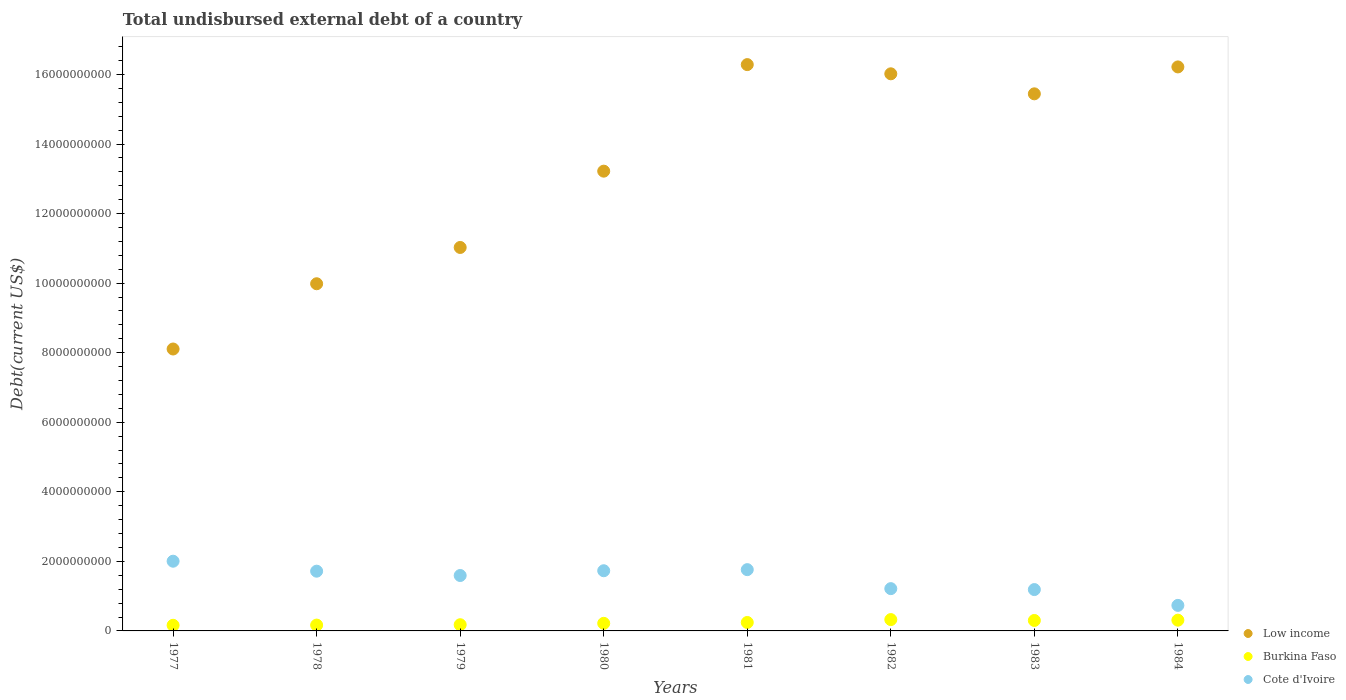How many different coloured dotlines are there?
Provide a succinct answer. 3. What is the total undisbursed external debt in Low income in 1982?
Keep it short and to the point. 1.60e+1. Across all years, what is the maximum total undisbursed external debt in Burkina Faso?
Ensure brevity in your answer.  3.26e+08. Across all years, what is the minimum total undisbursed external debt in Cote d'Ivoire?
Make the answer very short. 7.34e+08. What is the total total undisbursed external debt in Low income in the graph?
Provide a short and direct response. 1.06e+11. What is the difference between the total undisbursed external debt in Cote d'Ivoire in 1979 and that in 1984?
Provide a short and direct response. 8.59e+08. What is the difference between the total undisbursed external debt in Cote d'Ivoire in 1981 and the total undisbursed external debt in Low income in 1980?
Ensure brevity in your answer.  -1.15e+1. What is the average total undisbursed external debt in Burkina Faso per year?
Offer a terse response. 2.38e+08. In the year 1983, what is the difference between the total undisbursed external debt in Low income and total undisbursed external debt in Cote d'Ivoire?
Your answer should be compact. 1.43e+1. What is the ratio of the total undisbursed external debt in Burkina Faso in 1977 to that in 1982?
Your response must be concise. 0.5. What is the difference between the highest and the second highest total undisbursed external debt in Low income?
Provide a short and direct response. 6.65e+07. What is the difference between the highest and the lowest total undisbursed external debt in Low income?
Your answer should be very brief. 8.18e+09. Is the sum of the total undisbursed external debt in Burkina Faso in 1981 and 1983 greater than the maximum total undisbursed external debt in Low income across all years?
Your answer should be compact. No. Does the total undisbursed external debt in Cote d'Ivoire monotonically increase over the years?
Your response must be concise. No. How many dotlines are there?
Your answer should be compact. 3. How many years are there in the graph?
Make the answer very short. 8. What is the difference between two consecutive major ticks on the Y-axis?
Your answer should be very brief. 2.00e+09. What is the title of the graph?
Provide a succinct answer. Total undisbursed external debt of a country. Does "Zimbabwe" appear as one of the legend labels in the graph?
Provide a succinct answer. No. What is the label or title of the X-axis?
Your answer should be very brief. Years. What is the label or title of the Y-axis?
Your answer should be compact. Debt(current US$). What is the Debt(current US$) in Low income in 1977?
Keep it short and to the point. 8.11e+09. What is the Debt(current US$) in Burkina Faso in 1977?
Make the answer very short. 1.62e+08. What is the Debt(current US$) of Cote d'Ivoire in 1977?
Your response must be concise. 2.00e+09. What is the Debt(current US$) of Low income in 1978?
Keep it short and to the point. 9.98e+09. What is the Debt(current US$) in Burkina Faso in 1978?
Provide a short and direct response. 1.68e+08. What is the Debt(current US$) in Cote d'Ivoire in 1978?
Keep it short and to the point. 1.72e+09. What is the Debt(current US$) in Low income in 1979?
Keep it short and to the point. 1.10e+1. What is the Debt(current US$) of Burkina Faso in 1979?
Offer a very short reply. 1.78e+08. What is the Debt(current US$) of Cote d'Ivoire in 1979?
Offer a terse response. 1.59e+09. What is the Debt(current US$) of Low income in 1980?
Offer a very short reply. 1.32e+1. What is the Debt(current US$) in Burkina Faso in 1980?
Your answer should be compact. 2.18e+08. What is the Debt(current US$) in Cote d'Ivoire in 1980?
Your answer should be compact. 1.73e+09. What is the Debt(current US$) of Low income in 1981?
Keep it short and to the point. 1.63e+1. What is the Debt(current US$) in Burkina Faso in 1981?
Offer a terse response. 2.43e+08. What is the Debt(current US$) in Cote d'Ivoire in 1981?
Make the answer very short. 1.76e+09. What is the Debt(current US$) in Low income in 1982?
Keep it short and to the point. 1.60e+1. What is the Debt(current US$) in Burkina Faso in 1982?
Keep it short and to the point. 3.26e+08. What is the Debt(current US$) in Cote d'Ivoire in 1982?
Make the answer very short. 1.22e+09. What is the Debt(current US$) in Low income in 1983?
Your answer should be very brief. 1.54e+1. What is the Debt(current US$) of Burkina Faso in 1983?
Your response must be concise. 3.01e+08. What is the Debt(current US$) in Cote d'Ivoire in 1983?
Offer a very short reply. 1.19e+09. What is the Debt(current US$) in Low income in 1984?
Keep it short and to the point. 1.62e+1. What is the Debt(current US$) of Burkina Faso in 1984?
Offer a very short reply. 3.09e+08. What is the Debt(current US$) of Cote d'Ivoire in 1984?
Give a very brief answer. 7.34e+08. Across all years, what is the maximum Debt(current US$) of Low income?
Your answer should be compact. 1.63e+1. Across all years, what is the maximum Debt(current US$) in Burkina Faso?
Ensure brevity in your answer.  3.26e+08. Across all years, what is the maximum Debt(current US$) in Cote d'Ivoire?
Offer a very short reply. 2.00e+09. Across all years, what is the minimum Debt(current US$) of Low income?
Make the answer very short. 8.11e+09. Across all years, what is the minimum Debt(current US$) of Burkina Faso?
Make the answer very short. 1.62e+08. Across all years, what is the minimum Debt(current US$) of Cote d'Ivoire?
Ensure brevity in your answer.  7.34e+08. What is the total Debt(current US$) of Low income in the graph?
Offer a very short reply. 1.06e+11. What is the total Debt(current US$) in Burkina Faso in the graph?
Provide a succinct answer. 1.90e+09. What is the total Debt(current US$) of Cote d'Ivoire in the graph?
Provide a short and direct response. 1.19e+1. What is the difference between the Debt(current US$) of Low income in 1977 and that in 1978?
Your answer should be compact. -1.88e+09. What is the difference between the Debt(current US$) of Burkina Faso in 1977 and that in 1978?
Offer a terse response. -5.92e+06. What is the difference between the Debt(current US$) in Cote d'Ivoire in 1977 and that in 1978?
Your answer should be very brief. 2.87e+08. What is the difference between the Debt(current US$) in Low income in 1977 and that in 1979?
Your answer should be compact. -2.92e+09. What is the difference between the Debt(current US$) in Burkina Faso in 1977 and that in 1979?
Provide a short and direct response. -1.64e+07. What is the difference between the Debt(current US$) of Cote d'Ivoire in 1977 and that in 1979?
Ensure brevity in your answer.  4.11e+08. What is the difference between the Debt(current US$) in Low income in 1977 and that in 1980?
Offer a terse response. -5.11e+09. What is the difference between the Debt(current US$) in Burkina Faso in 1977 and that in 1980?
Your answer should be compact. -5.63e+07. What is the difference between the Debt(current US$) of Cote d'Ivoire in 1977 and that in 1980?
Offer a very short reply. 2.74e+08. What is the difference between the Debt(current US$) of Low income in 1977 and that in 1981?
Provide a short and direct response. -8.18e+09. What is the difference between the Debt(current US$) of Burkina Faso in 1977 and that in 1981?
Offer a terse response. -8.09e+07. What is the difference between the Debt(current US$) in Cote d'Ivoire in 1977 and that in 1981?
Provide a succinct answer. 2.42e+08. What is the difference between the Debt(current US$) of Low income in 1977 and that in 1982?
Your answer should be compact. -7.91e+09. What is the difference between the Debt(current US$) in Burkina Faso in 1977 and that in 1982?
Offer a very short reply. -1.64e+08. What is the difference between the Debt(current US$) of Cote d'Ivoire in 1977 and that in 1982?
Keep it short and to the point. 7.89e+08. What is the difference between the Debt(current US$) in Low income in 1977 and that in 1983?
Keep it short and to the point. -7.34e+09. What is the difference between the Debt(current US$) in Burkina Faso in 1977 and that in 1983?
Offer a terse response. -1.39e+08. What is the difference between the Debt(current US$) of Cote d'Ivoire in 1977 and that in 1983?
Offer a very short reply. 8.15e+08. What is the difference between the Debt(current US$) in Low income in 1977 and that in 1984?
Ensure brevity in your answer.  -8.11e+09. What is the difference between the Debt(current US$) of Burkina Faso in 1977 and that in 1984?
Your answer should be compact. -1.47e+08. What is the difference between the Debt(current US$) of Cote d'Ivoire in 1977 and that in 1984?
Offer a terse response. 1.27e+09. What is the difference between the Debt(current US$) in Low income in 1978 and that in 1979?
Give a very brief answer. -1.04e+09. What is the difference between the Debt(current US$) of Burkina Faso in 1978 and that in 1979?
Your response must be concise. -1.04e+07. What is the difference between the Debt(current US$) of Cote d'Ivoire in 1978 and that in 1979?
Ensure brevity in your answer.  1.24e+08. What is the difference between the Debt(current US$) of Low income in 1978 and that in 1980?
Keep it short and to the point. -3.24e+09. What is the difference between the Debt(current US$) of Burkina Faso in 1978 and that in 1980?
Ensure brevity in your answer.  -5.04e+07. What is the difference between the Debt(current US$) of Cote d'Ivoire in 1978 and that in 1980?
Provide a succinct answer. -1.27e+07. What is the difference between the Debt(current US$) in Low income in 1978 and that in 1981?
Your response must be concise. -6.30e+09. What is the difference between the Debt(current US$) in Burkina Faso in 1978 and that in 1981?
Provide a short and direct response. -7.50e+07. What is the difference between the Debt(current US$) of Cote d'Ivoire in 1978 and that in 1981?
Make the answer very short. -4.43e+07. What is the difference between the Debt(current US$) in Low income in 1978 and that in 1982?
Your response must be concise. -6.04e+09. What is the difference between the Debt(current US$) in Burkina Faso in 1978 and that in 1982?
Your answer should be very brief. -1.58e+08. What is the difference between the Debt(current US$) in Cote d'Ivoire in 1978 and that in 1982?
Ensure brevity in your answer.  5.02e+08. What is the difference between the Debt(current US$) in Low income in 1978 and that in 1983?
Provide a succinct answer. -5.46e+09. What is the difference between the Debt(current US$) of Burkina Faso in 1978 and that in 1983?
Ensure brevity in your answer.  -1.33e+08. What is the difference between the Debt(current US$) of Cote d'Ivoire in 1978 and that in 1983?
Ensure brevity in your answer.  5.29e+08. What is the difference between the Debt(current US$) of Low income in 1978 and that in 1984?
Keep it short and to the point. -6.23e+09. What is the difference between the Debt(current US$) of Burkina Faso in 1978 and that in 1984?
Offer a terse response. -1.41e+08. What is the difference between the Debt(current US$) of Cote d'Ivoire in 1978 and that in 1984?
Provide a succinct answer. 9.83e+08. What is the difference between the Debt(current US$) of Low income in 1979 and that in 1980?
Ensure brevity in your answer.  -2.19e+09. What is the difference between the Debt(current US$) of Burkina Faso in 1979 and that in 1980?
Your answer should be compact. -3.99e+07. What is the difference between the Debt(current US$) in Cote d'Ivoire in 1979 and that in 1980?
Provide a short and direct response. -1.37e+08. What is the difference between the Debt(current US$) in Low income in 1979 and that in 1981?
Make the answer very short. -5.26e+09. What is the difference between the Debt(current US$) in Burkina Faso in 1979 and that in 1981?
Your answer should be compact. -6.45e+07. What is the difference between the Debt(current US$) of Cote d'Ivoire in 1979 and that in 1981?
Your answer should be very brief. -1.69e+08. What is the difference between the Debt(current US$) in Low income in 1979 and that in 1982?
Your answer should be very brief. -4.99e+09. What is the difference between the Debt(current US$) in Burkina Faso in 1979 and that in 1982?
Your answer should be compact. -1.48e+08. What is the difference between the Debt(current US$) in Cote d'Ivoire in 1979 and that in 1982?
Give a very brief answer. 3.78e+08. What is the difference between the Debt(current US$) in Low income in 1979 and that in 1983?
Make the answer very short. -4.42e+09. What is the difference between the Debt(current US$) of Burkina Faso in 1979 and that in 1983?
Offer a very short reply. -1.22e+08. What is the difference between the Debt(current US$) of Cote d'Ivoire in 1979 and that in 1983?
Provide a short and direct response. 4.04e+08. What is the difference between the Debt(current US$) in Low income in 1979 and that in 1984?
Provide a short and direct response. -5.19e+09. What is the difference between the Debt(current US$) in Burkina Faso in 1979 and that in 1984?
Offer a very short reply. -1.31e+08. What is the difference between the Debt(current US$) in Cote d'Ivoire in 1979 and that in 1984?
Offer a terse response. 8.59e+08. What is the difference between the Debt(current US$) of Low income in 1980 and that in 1981?
Give a very brief answer. -3.06e+09. What is the difference between the Debt(current US$) of Burkina Faso in 1980 and that in 1981?
Provide a succinct answer. -2.46e+07. What is the difference between the Debt(current US$) of Cote d'Ivoire in 1980 and that in 1981?
Your answer should be very brief. -3.16e+07. What is the difference between the Debt(current US$) in Low income in 1980 and that in 1982?
Your answer should be very brief. -2.80e+09. What is the difference between the Debt(current US$) of Burkina Faso in 1980 and that in 1982?
Offer a terse response. -1.08e+08. What is the difference between the Debt(current US$) of Cote d'Ivoire in 1980 and that in 1982?
Keep it short and to the point. 5.15e+08. What is the difference between the Debt(current US$) of Low income in 1980 and that in 1983?
Provide a succinct answer. -2.22e+09. What is the difference between the Debt(current US$) of Burkina Faso in 1980 and that in 1983?
Make the answer very short. -8.23e+07. What is the difference between the Debt(current US$) in Cote d'Ivoire in 1980 and that in 1983?
Ensure brevity in your answer.  5.42e+08. What is the difference between the Debt(current US$) in Low income in 1980 and that in 1984?
Give a very brief answer. -3.00e+09. What is the difference between the Debt(current US$) of Burkina Faso in 1980 and that in 1984?
Make the answer very short. -9.08e+07. What is the difference between the Debt(current US$) in Cote d'Ivoire in 1980 and that in 1984?
Offer a very short reply. 9.96e+08. What is the difference between the Debt(current US$) of Low income in 1981 and that in 1982?
Your answer should be very brief. 2.65e+08. What is the difference between the Debt(current US$) of Burkina Faso in 1981 and that in 1982?
Provide a short and direct response. -8.32e+07. What is the difference between the Debt(current US$) of Cote d'Ivoire in 1981 and that in 1982?
Provide a succinct answer. 5.46e+08. What is the difference between the Debt(current US$) in Low income in 1981 and that in 1983?
Provide a succinct answer. 8.40e+08. What is the difference between the Debt(current US$) of Burkina Faso in 1981 and that in 1983?
Your response must be concise. -5.77e+07. What is the difference between the Debt(current US$) of Cote d'Ivoire in 1981 and that in 1983?
Provide a succinct answer. 5.73e+08. What is the difference between the Debt(current US$) in Low income in 1981 and that in 1984?
Provide a succinct answer. 6.65e+07. What is the difference between the Debt(current US$) in Burkina Faso in 1981 and that in 1984?
Your answer should be very brief. -6.62e+07. What is the difference between the Debt(current US$) in Cote d'Ivoire in 1981 and that in 1984?
Make the answer very short. 1.03e+09. What is the difference between the Debt(current US$) in Low income in 1982 and that in 1983?
Your answer should be very brief. 5.76e+08. What is the difference between the Debt(current US$) in Burkina Faso in 1982 and that in 1983?
Keep it short and to the point. 2.54e+07. What is the difference between the Debt(current US$) of Cote d'Ivoire in 1982 and that in 1983?
Keep it short and to the point. 2.68e+07. What is the difference between the Debt(current US$) of Low income in 1982 and that in 1984?
Offer a very short reply. -1.98e+08. What is the difference between the Debt(current US$) of Burkina Faso in 1982 and that in 1984?
Offer a terse response. 1.69e+07. What is the difference between the Debt(current US$) of Cote d'Ivoire in 1982 and that in 1984?
Offer a terse response. 4.82e+08. What is the difference between the Debt(current US$) of Low income in 1983 and that in 1984?
Ensure brevity in your answer.  -7.74e+08. What is the difference between the Debt(current US$) of Burkina Faso in 1983 and that in 1984?
Offer a very short reply. -8.50e+06. What is the difference between the Debt(current US$) of Cote d'Ivoire in 1983 and that in 1984?
Provide a short and direct response. 4.55e+08. What is the difference between the Debt(current US$) in Low income in 1977 and the Debt(current US$) in Burkina Faso in 1978?
Offer a very short reply. 7.94e+09. What is the difference between the Debt(current US$) of Low income in 1977 and the Debt(current US$) of Cote d'Ivoire in 1978?
Your answer should be compact. 6.39e+09. What is the difference between the Debt(current US$) of Burkina Faso in 1977 and the Debt(current US$) of Cote d'Ivoire in 1978?
Ensure brevity in your answer.  -1.56e+09. What is the difference between the Debt(current US$) of Low income in 1977 and the Debt(current US$) of Burkina Faso in 1979?
Your answer should be compact. 7.93e+09. What is the difference between the Debt(current US$) in Low income in 1977 and the Debt(current US$) in Cote d'Ivoire in 1979?
Your answer should be compact. 6.51e+09. What is the difference between the Debt(current US$) in Burkina Faso in 1977 and the Debt(current US$) in Cote d'Ivoire in 1979?
Your answer should be compact. -1.43e+09. What is the difference between the Debt(current US$) in Low income in 1977 and the Debt(current US$) in Burkina Faso in 1980?
Offer a very short reply. 7.89e+09. What is the difference between the Debt(current US$) of Low income in 1977 and the Debt(current US$) of Cote d'Ivoire in 1980?
Your response must be concise. 6.38e+09. What is the difference between the Debt(current US$) of Burkina Faso in 1977 and the Debt(current US$) of Cote d'Ivoire in 1980?
Offer a terse response. -1.57e+09. What is the difference between the Debt(current US$) of Low income in 1977 and the Debt(current US$) of Burkina Faso in 1981?
Provide a short and direct response. 7.86e+09. What is the difference between the Debt(current US$) in Low income in 1977 and the Debt(current US$) in Cote d'Ivoire in 1981?
Your response must be concise. 6.34e+09. What is the difference between the Debt(current US$) in Burkina Faso in 1977 and the Debt(current US$) in Cote d'Ivoire in 1981?
Give a very brief answer. -1.60e+09. What is the difference between the Debt(current US$) in Low income in 1977 and the Debt(current US$) in Burkina Faso in 1982?
Keep it short and to the point. 7.78e+09. What is the difference between the Debt(current US$) of Low income in 1977 and the Debt(current US$) of Cote d'Ivoire in 1982?
Ensure brevity in your answer.  6.89e+09. What is the difference between the Debt(current US$) in Burkina Faso in 1977 and the Debt(current US$) in Cote d'Ivoire in 1982?
Offer a very short reply. -1.05e+09. What is the difference between the Debt(current US$) in Low income in 1977 and the Debt(current US$) in Burkina Faso in 1983?
Give a very brief answer. 7.81e+09. What is the difference between the Debt(current US$) in Low income in 1977 and the Debt(current US$) in Cote d'Ivoire in 1983?
Ensure brevity in your answer.  6.92e+09. What is the difference between the Debt(current US$) in Burkina Faso in 1977 and the Debt(current US$) in Cote d'Ivoire in 1983?
Give a very brief answer. -1.03e+09. What is the difference between the Debt(current US$) of Low income in 1977 and the Debt(current US$) of Burkina Faso in 1984?
Your answer should be very brief. 7.80e+09. What is the difference between the Debt(current US$) in Low income in 1977 and the Debt(current US$) in Cote d'Ivoire in 1984?
Provide a short and direct response. 7.37e+09. What is the difference between the Debt(current US$) in Burkina Faso in 1977 and the Debt(current US$) in Cote d'Ivoire in 1984?
Offer a terse response. -5.72e+08. What is the difference between the Debt(current US$) in Low income in 1978 and the Debt(current US$) in Burkina Faso in 1979?
Provide a succinct answer. 9.80e+09. What is the difference between the Debt(current US$) in Low income in 1978 and the Debt(current US$) in Cote d'Ivoire in 1979?
Offer a terse response. 8.39e+09. What is the difference between the Debt(current US$) in Burkina Faso in 1978 and the Debt(current US$) in Cote d'Ivoire in 1979?
Your answer should be compact. -1.43e+09. What is the difference between the Debt(current US$) in Low income in 1978 and the Debt(current US$) in Burkina Faso in 1980?
Provide a succinct answer. 9.76e+09. What is the difference between the Debt(current US$) of Low income in 1978 and the Debt(current US$) of Cote d'Ivoire in 1980?
Offer a very short reply. 8.25e+09. What is the difference between the Debt(current US$) in Burkina Faso in 1978 and the Debt(current US$) in Cote d'Ivoire in 1980?
Offer a terse response. -1.56e+09. What is the difference between the Debt(current US$) of Low income in 1978 and the Debt(current US$) of Burkina Faso in 1981?
Provide a short and direct response. 9.74e+09. What is the difference between the Debt(current US$) in Low income in 1978 and the Debt(current US$) in Cote d'Ivoire in 1981?
Your response must be concise. 8.22e+09. What is the difference between the Debt(current US$) in Burkina Faso in 1978 and the Debt(current US$) in Cote d'Ivoire in 1981?
Offer a very short reply. -1.59e+09. What is the difference between the Debt(current US$) of Low income in 1978 and the Debt(current US$) of Burkina Faso in 1982?
Offer a very short reply. 9.66e+09. What is the difference between the Debt(current US$) of Low income in 1978 and the Debt(current US$) of Cote d'Ivoire in 1982?
Give a very brief answer. 8.77e+09. What is the difference between the Debt(current US$) in Burkina Faso in 1978 and the Debt(current US$) in Cote d'Ivoire in 1982?
Give a very brief answer. -1.05e+09. What is the difference between the Debt(current US$) of Low income in 1978 and the Debt(current US$) of Burkina Faso in 1983?
Your answer should be very brief. 9.68e+09. What is the difference between the Debt(current US$) in Low income in 1978 and the Debt(current US$) in Cote d'Ivoire in 1983?
Your answer should be compact. 8.79e+09. What is the difference between the Debt(current US$) of Burkina Faso in 1978 and the Debt(current US$) of Cote d'Ivoire in 1983?
Offer a terse response. -1.02e+09. What is the difference between the Debt(current US$) of Low income in 1978 and the Debt(current US$) of Burkina Faso in 1984?
Give a very brief answer. 9.67e+09. What is the difference between the Debt(current US$) of Low income in 1978 and the Debt(current US$) of Cote d'Ivoire in 1984?
Make the answer very short. 9.25e+09. What is the difference between the Debt(current US$) of Burkina Faso in 1978 and the Debt(current US$) of Cote d'Ivoire in 1984?
Ensure brevity in your answer.  -5.66e+08. What is the difference between the Debt(current US$) of Low income in 1979 and the Debt(current US$) of Burkina Faso in 1980?
Your response must be concise. 1.08e+1. What is the difference between the Debt(current US$) in Low income in 1979 and the Debt(current US$) in Cote d'Ivoire in 1980?
Offer a terse response. 9.30e+09. What is the difference between the Debt(current US$) in Burkina Faso in 1979 and the Debt(current US$) in Cote d'Ivoire in 1980?
Ensure brevity in your answer.  -1.55e+09. What is the difference between the Debt(current US$) of Low income in 1979 and the Debt(current US$) of Burkina Faso in 1981?
Offer a terse response. 1.08e+1. What is the difference between the Debt(current US$) in Low income in 1979 and the Debt(current US$) in Cote d'Ivoire in 1981?
Make the answer very short. 9.26e+09. What is the difference between the Debt(current US$) in Burkina Faso in 1979 and the Debt(current US$) in Cote d'Ivoire in 1981?
Offer a terse response. -1.58e+09. What is the difference between the Debt(current US$) in Low income in 1979 and the Debt(current US$) in Burkina Faso in 1982?
Keep it short and to the point. 1.07e+1. What is the difference between the Debt(current US$) of Low income in 1979 and the Debt(current US$) of Cote d'Ivoire in 1982?
Offer a very short reply. 9.81e+09. What is the difference between the Debt(current US$) of Burkina Faso in 1979 and the Debt(current US$) of Cote d'Ivoire in 1982?
Your response must be concise. -1.04e+09. What is the difference between the Debt(current US$) in Low income in 1979 and the Debt(current US$) in Burkina Faso in 1983?
Your answer should be compact. 1.07e+1. What is the difference between the Debt(current US$) in Low income in 1979 and the Debt(current US$) in Cote d'Ivoire in 1983?
Your response must be concise. 9.84e+09. What is the difference between the Debt(current US$) in Burkina Faso in 1979 and the Debt(current US$) in Cote d'Ivoire in 1983?
Ensure brevity in your answer.  -1.01e+09. What is the difference between the Debt(current US$) in Low income in 1979 and the Debt(current US$) in Burkina Faso in 1984?
Make the answer very short. 1.07e+1. What is the difference between the Debt(current US$) in Low income in 1979 and the Debt(current US$) in Cote d'Ivoire in 1984?
Offer a terse response. 1.03e+1. What is the difference between the Debt(current US$) in Burkina Faso in 1979 and the Debt(current US$) in Cote d'Ivoire in 1984?
Your answer should be very brief. -5.56e+08. What is the difference between the Debt(current US$) of Low income in 1980 and the Debt(current US$) of Burkina Faso in 1981?
Offer a terse response. 1.30e+1. What is the difference between the Debt(current US$) of Low income in 1980 and the Debt(current US$) of Cote d'Ivoire in 1981?
Your answer should be very brief. 1.15e+1. What is the difference between the Debt(current US$) of Burkina Faso in 1980 and the Debt(current US$) of Cote d'Ivoire in 1981?
Your response must be concise. -1.54e+09. What is the difference between the Debt(current US$) of Low income in 1980 and the Debt(current US$) of Burkina Faso in 1982?
Make the answer very short. 1.29e+1. What is the difference between the Debt(current US$) of Low income in 1980 and the Debt(current US$) of Cote d'Ivoire in 1982?
Make the answer very short. 1.20e+1. What is the difference between the Debt(current US$) in Burkina Faso in 1980 and the Debt(current US$) in Cote d'Ivoire in 1982?
Ensure brevity in your answer.  -9.98e+08. What is the difference between the Debt(current US$) of Low income in 1980 and the Debt(current US$) of Burkina Faso in 1983?
Your answer should be compact. 1.29e+1. What is the difference between the Debt(current US$) of Low income in 1980 and the Debt(current US$) of Cote d'Ivoire in 1983?
Offer a very short reply. 1.20e+1. What is the difference between the Debt(current US$) in Burkina Faso in 1980 and the Debt(current US$) in Cote d'Ivoire in 1983?
Make the answer very short. -9.71e+08. What is the difference between the Debt(current US$) of Low income in 1980 and the Debt(current US$) of Burkina Faso in 1984?
Keep it short and to the point. 1.29e+1. What is the difference between the Debt(current US$) of Low income in 1980 and the Debt(current US$) of Cote d'Ivoire in 1984?
Keep it short and to the point. 1.25e+1. What is the difference between the Debt(current US$) in Burkina Faso in 1980 and the Debt(current US$) in Cote d'Ivoire in 1984?
Your answer should be compact. -5.16e+08. What is the difference between the Debt(current US$) of Low income in 1981 and the Debt(current US$) of Burkina Faso in 1982?
Ensure brevity in your answer.  1.60e+1. What is the difference between the Debt(current US$) of Low income in 1981 and the Debt(current US$) of Cote d'Ivoire in 1982?
Ensure brevity in your answer.  1.51e+1. What is the difference between the Debt(current US$) of Burkina Faso in 1981 and the Debt(current US$) of Cote d'Ivoire in 1982?
Give a very brief answer. -9.73e+08. What is the difference between the Debt(current US$) of Low income in 1981 and the Debt(current US$) of Burkina Faso in 1983?
Offer a terse response. 1.60e+1. What is the difference between the Debt(current US$) in Low income in 1981 and the Debt(current US$) in Cote d'Ivoire in 1983?
Provide a succinct answer. 1.51e+1. What is the difference between the Debt(current US$) in Burkina Faso in 1981 and the Debt(current US$) in Cote d'Ivoire in 1983?
Give a very brief answer. -9.46e+08. What is the difference between the Debt(current US$) in Low income in 1981 and the Debt(current US$) in Burkina Faso in 1984?
Offer a terse response. 1.60e+1. What is the difference between the Debt(current US$) in Low income in 1981 and the Debt(current US$) in Cote d'Ivoire in 1984?
Your answer should be very brief. 1.55e+1. What is the difference between the Debt(current US$) in Burkina Faso in 1981 and the Debt(current US$) in Cote d'Ivoire in 1984?
Provide a short and direct response. -4.91e+08. What is the difference between the Debt(current US$) of Low income in 1982 and the Debt(current US$) of Burkina Faso in 1983?
Your answer should be compact. 1.57e+1. What is the difference between the Debt(current US$) of Low income in 1982 and the Debt(current US$) of Cote d'Ivoire in 1983?
Your answer should be very brief. 1.48e+1. What is the difference between the Debt(current US$) in Burkina Faso in 1982 and the Debt(current US$) in Cote d'Ivoire in 1983?
Your answer should be compact. -8.63e+08. What is the difference between the Debt(current US$) in Low income in 1982 and the Debt(current US$) in Burkina Faso in 1984?
Your answer should be compact. 1.57e+1. What is the difference between the Debt(current US$) of Low income in 1982 and the Debt(current US$) of Cote d'Ivoire in 1984?
Provide a succinct answer. 1.53e+1. What is the difference between the Debt(current US$) of Burkina Faso in 1982 and the Debt(current US$) of Cote d'Ivoire in 1984?
Make the answer very short. -4.08e+08. What is the difference between the Debt(current US$) in Low income in 1983 and the Debt(current US$) in Burkina Faso in 1984?
Your answer should be compact. 1.51e+1. What is the difference between the Debt(current US$) of Low income in 1983 and the Debt(current US$) of Cote d'Ivoire in 1984?
Your answer should be very brief. 1.47e+1. What is the difference between the Debt(current US$) of Burkina Faso in 1983 and the Debt(current US$) of Cote d'Ivoire in 1984?
Keep it short and to the point. -4.34e+08. What is the average Debt(current US$) of Low income per year?
Provide a short and direct response. 1.33e+1. What is the average Debt(current US$) in Burkina Faso per year?
Offer a very short reply. 2.38e+08. What is the average Debt(current US$) of Cote d'Ivoire per year?
Provide a short and direct response. 1.49e+09. In the year 1977, what is the difference between the Debt(current US$) of Low income and Debt(current US$) of Burkina Faso?
Give a very brief answer. 7.94e+09. In the year 1977, what is the difference between the Debt(current US$) of Low income and Debt(current US$) of Cote d'Ivoire?
Keep it short and to the point. 6.10e+09. In the year 1977, what is the difference between the Debt(current US$) in Burkina Faso and Debt(current US$) in Cote d'Ivoire?
Provide a succinct answer. -1.84e+09. In the year 1978, what is the difference between the Debt(current US$) of Low income and Debt(current US$) of Burkina Faso?
Ensure brevity in your answer.  9.82e+09. In the year 1978, what is the difference between the Debt(current US$) of Low income and Debt(current US$) of Cote d'Ivoire?
Offer a very short reply. 8.27e+09. In the year 1978, what is the difference between the Debt(current US$) of Burkina Faso and Debt(current US$) of Cote d'Ivoire?
Give a very brief answer. -1.55e+09. In the year 1979, what is the difference between the Debt(current US$) of Low income and Debt(current US$) of Burkina Faso?
Make the answer very short. 1.08e+1. In the year 1979, what is the difference between the Debt(current US$) in Low income and Debt(current US$) in Cote d'Ivoire?
Offer a very short reply. 9.43e+09. In the year 1979, what is the difference between the Debt(current US$) of Burkina Faso and Debt(current US$) of Cote d'Ivoire?
Your answer should be very brief. -1.42e+09. In the year 1980, what is the difference between the Debt(current US$) of Low income and Debt(current US$) of Burkina Faso?
Make the answer very short. 1.30e+1. In the year 1980, what is the difference between the Debt(current US$) in Low income and Debt(current US$) in Cote d'Ivoire?
Make the answer very short. 1.15e+1. In the year 1980, what is the difference between the Debt(current US$) of Burkina Faso and Debt(current US$) of Cote d'Ivoire?
Provide a short and direct response. -1.51e+09. In the year 1981, what is the difference between the Debt(current US$) of Low income and Debt(current US$) of Burkina Faso?
Provide a short and direct response. 1.60e+1. In the year 1981, what is the difference between the Debt(current US$) of Low income and Debt(current US$) of Cote d'Ivoire?
Provide a succinct answer. 1.45e+1. In the year 1981, what is the difference between the Debt(current US$) in Burkina Faso and Debt(current US$) in Cote d'Ivoire?
Your answer should be very brief. -1.52e+09. In the year 1982, what is the difference between the Debt(current US$) in Low income and Debt(current US$) in Burkina Faso?
Keep it short and to the point. 1.57e+1. In the year 1982, what is the difference between the Debt(current US$) in Low income and Debt(current US$) in Cote d'Ivoire?
Offer a very short reply. 1.48e+1. In the year 1982, what is the difference between the Debt(current US$) in Burkina Faso and Debt(current US$) in Cote d'Ivoire?
Ensure brevity in your answer.  -8.90e+08. In the year 1983, what is the difference between the Debt(current US$) in Low income and Debt(current US$) in Burkina Faso?
Give a very brief answer. 1.51e+1. In the year 1983, what is the difference between the Debt(current US$) of Low income and Debt(current US$) of Cote d'Ivoire?
Provide a short and direct response. 1.43e+1. In the year 1983, what is the difference between the Debt(current US$) of Burkina Faso and Debt(current US$) of Cote d'Ivoire?
Ensure brevity in your answer.  -8.88e+08. In the year 1984, what is the difference between the Debt(current US$) in Low income and Debt(current US$) in Burkina Faso?
Provide a succinct answer. 1.59e+1. In the year 1984, what is the difference between the Debt(current US$) of Low income and Debt(current US$) of Cote d'Ivoire?
Ensure brevity in your answer.  1.55e+1. In the year 1984, what is the difference between the Debt(current US$) of Burkina Faso and Debt(current US$) of Cote d'Ivoire?
Provide a succinct answer. -4.25e+08. What is the ratio of the Debt(current US$) in Low income in 1977 to that in 1978?
Ensure brevity in your answer.  0.81. What is the ratio of the Debt(current US$) of Burkina Faso in 1977 to that in 1978?
Offer a very short reply. 0.96. What is the ratio of the Debt(current US$) of Cote d'Ivoire in 1977 to that in 1978?
Your response must be concise. 1.17. What is the ratio of the Debt(current US$) in Low income in 1977 to that in 1979?
Your answer should be compact. 0.74. What is the ratio of the Debt(current US$) of Burkina Faso in 1977 to that in 1979?
Keep it short and to the point. 0.91. What is the ratio of the Debt(current US$) of Cote d'Ivoire in 1977 to that in 1979?
Make the answer very short. 1.26. What is the ratio of the Debt(current US$) of Low income in 1977 to that in 1980?
Your response must be concise. 0.61. What is the ratio of the Debt(current US$) of Burkina Faso in 1977 to that in 1980?
Provide a succinct answer. 0.74. What is the ratio of the Debt(current US$) of Cote d'Ivoire in 1977 to that in 1980?
Provide a short and direct response. 1.16. What is the ratio of the Debt(current US$) of Low income in 1977 to that in 1981?
Your answer should be very brief. 0.5. What is the ratio of the Debt(current US$) in Burkina Faso in 1977 to that in 1981?
Offer a very short reply. 0.67. What is the ratio of the Debt(current US$) of Cote d'Ivoire in 1977 to that in 1981?
Your response must be concise. 1.14. What is the ratio of the Debt(current US$) of Low income in 1977 to that in 1982?
Provide a succinct answer. 0.51. What is the ratio of the Debt(current US$) in Burkina Faso in 1977 to that in 1982?
Keep it short and to the point. 0.5. What is the ratio of the Debt(current US$) in Cote d'Ivoire in 1977 to that in 1982?
Make the answer very short. 1.65. What is the ratio of the Debt(current US$) of Low income in 1977 to that in 1983?
Provide a succinct answer. 0.52. What is the ratio of the Debt(current US$) of Burkina Faso in 1977 to that in 1983?
Give a very brief answer. 0.54. What is the ratio of the Debt(current US$) of Cote d'Ivoire in 1977 to that in 1983?
Give a very brief answer. 1.69. What is the ratio of the Debt(current US$) of Low income in 1977 to that in 1984?
Make the answer very short. 0.5. What is the ratio of the Debt(current US$) in Burkina Faso in 1977 to that in 1984?
Your answer should be compact. 0.52. What is the ratio of the Debt(current US$) in Cote d'Ivoire in 1977 to that in 1984?
Make the answer very short. 2.73. What is the ratio of the Debt(current US$) of Low income in 1978 to that in 1979?
Your answer should be very brief. 0.91. What is the ratio of the Debt(current US$) of Burkina Faso in 1978 to that in 1979?
Your answer should be compact. 0.94. What is the ratio of the Debt(current US$) of Cote d'Ivoire in 1978 to that in 1979?
Your response must be concise. 1.08. What is the ratio of the Debt(current US$) of Low income in 1978 to that in 1980?
Provide a succinct answer. 0.76. What is the ratio of the Debt(current US$) in Burkina Faso in 1978 to that in 1980?
Make the answer very short. 0.77. What is the ratio of the Debt(current US$) of Cote d'Ivoire in 1978 to that in 1980?
Ensure brevity in your answer.  0.99. What is the ratio of the Debt(current US$) in Low income in 1978 to that in 1981?
Your answer should be compact. 0.61. What is the ratio of the Debt(current US$) in Burkina Faso in 1978 to that in 1981?
Offer a terse response. 0.69. What is the ratio of the Debt(current US$) of Cote d'Ivoire in 1978 to that in 1981?
Your answer should be very brief. 0.97. What is the ratio of the Debt(current US$) in Low income in 1978 to that in 1982?
Your answer should be compact. 0.62. What is the ratio of the Debt(current US$) in Burkina Faso in 1978 to that in 1982?
Your response must be concise. 0.52. What is the ratio of the Debt(current US$) in Cote d'Ivoire in 1978 to that in 1982?
Offer a very short reply. 1.41. What is the ratio of the Debt(current US$) in Low income in 1978 to that in 1983?
Provide a succinct answer. 0.65. What is the ratio of the Debt(current US$) of Burkina Faso in 1978 to that in 1983?
Ensure brevity in your answer.  0.56. What is the ratio of the Debt(current US$) in Cote d'Ivoire in 1978 to that in 1983?
Your answer should be very brief. 1.44. What is the ratio of the Debt(current US$) in Low income in 1978 to that in 1984?
Your answer should be very brief. 0.62. What is the ratio of the Debt(current US$) of Burkina Faso in 1978 to that in 1984?
Your answer should be very brief. 0.54. What is the ratio of the Debt(current US$) of Cote d'Ivoire in 1978 to that in 1984?
Your response must be concise. 2.34. What is the ratio of the Debt(current US$) in Low income in 1979 to that in 1980?
Your answer should be compact. 0.83. What is the ratio of the Debt(current US$) in Burkina Faso in 1979 to that in 1980?
Offer a terse response. 0.82. What is the ratio of the Debt(current US$) of Cote d'Ivoire in 1979 to that in 1980?
Give a very brief answer. 0.92. What is the ratio of the Debt(current US$) in Low income in 1979 to that in 1981?
Offer a terse response. 0.68. What is the ratio of the Debt(current US$) in Burkina Faso in 1979 to that in 1981?
Ensure brevity in your answer.  0.73. What is the ratio of the Debt(current US$) in Cote d'Ivoire in 1979 to that in 1981?
Provide a succinct answer. 0.9. What is the ratio of the Debt(current US$) of Low income in 1979 to that in 1982?
Offer a very short reply. 0.69. What is the ratio of the Debt(current US$) in Burkina Faso in 1979 to that in 1982?
Ensure brevity in your answer.  0.55. What is the ratio of the Debt(current US$) of Cote d'Ivoire in 1979 to that in 1982?
Keep it short and to the point. 1.31. What is the ratio of the Debt(current US$) in Low income in 1979 to that in 1983?
Your answer should be compact. 0.71. What is the ratio of the Debt(current US$) in Burkina Faso in 1979 to that in 1983?
Offer a very short reply. 0.59. What is the ratio of the Debt(current US$) of Cote d'Ivoire in 1979 to that in 1983?
Make the answer very short. 1.34. What is the ratio of the Debt(current US$) of Low income in 1979 to that in 1984?
Keep it short and to the point. 0.68. What is the ratio of the Debt(current US$) in Burkina Faso in 1979 to that in 1984?
Your response must be concise. 0.58. What is the ratio of the Debt(current US$) in Cote d'Ivoire in 1979 to that in 1984?
Provide a short and direct response. 2.17. What is the ratio of the Debt(current US$) in Low income in 1980 to that in 1981?
Offer a terse response. 0.81. What is the ratio of the Debt(current US$) in Burkina Faso in 1980 to that in 1981?
Offer a very short reply. 0.9. What is the ratio of the Debt(current US$) of Cote d'Ivoire in 1980 to that in 1981?
Give a very brief answer. 0.98. What is the ratio of the Debt(current US$) in Low income in 1980 to that in 1982?
Make the answer very short. 0.83. What is the ratio of the Debt(current US$) in Burkina Faso in 1980 to that in 1982?
Keep it short and to the point. 0.67. What is the ratio of the Debt(current US$) in Cote d'Ivoire in 1980 to that in 1982?
Make the answer very short. 1.42. What is the ratio of the Debt(current US$) in Low income in 1980 to that in 1983?
Offer a terse response. 0.86. What is the ratio of the Debt(current US$) in Burkina Faso in 1980 to that in 1983?
Offer a very short reply. 0.73. What is the ratio of the Debt(current US$) in Cote d'Ivoire in 1980 to that in 1983?
Provide a short and direct response. 1.46. What is the ratio of the Debt(current US$) in Low income in 1980 to that in 1984?
Ensure brevity in your answer.  0.82. What is the ratio of the Debt(current US$) of Burkina Faso in 1980 to that in 1984?
Give a very brief answer. 0.71. What is the ratio of the Debt(current US$) of Cote d'Ivoire in 1980 to that in 1984?
Your answer should be very brief. 2.36. What is the ratio of the Debt(current US$) of Low income in 1981 to that in 1982?
Your answer should be very brief. 1.02. What is the ratio of the Debt(current US$) of Burkina Faso in 1981 to that in 1982?
Ensure brevity in your answer.  0.74. What is the ratio of the Debt(current US$) in Cote d'Ivoire in 1981 to that in 1982?
Your answer should be very brief. 1.45. What is the ratio of the Debt(current US$) of Low income in 1981 to that in 1983?
Provide a short and direct response. 1.05. What is the ratio of the Debt(current US$) of Burkina Faso in 1981 to that in 1983?
Provide a succinct answer. 0.81. What is the ratio of the Debt(current US$) in Cote d'Ivoire in 1981 to that in 1983?
Your response must be concise. 1.48. What is the ratio of the Debt(current US$) of Low income in 1981 to that in 1984?
Your answer should be compact. 1. What is the ratio of the Debt(current US$) of Burkina Faso in 1981 to that in 1984?
Offer a very short reply. 0.79. What is the ratio of the Debt(current US$) of Cote d'Ivoire in 1981 to that in 1984?
Offer a terse response. 2.4. What is the ratio of the Debt(current US$) in Low income in 1982 to that in 1983?
Give a very brief answer. 1.04. What is the ratio of the Debt(current US$) in Burkina Faso in 1982 to that in 1983?
Your answer should be very brief. 1.08. What is the ratio of the Debt(current US$) of Cote d'Ivoire in 1982 to that in 1983?
Your answer should be very brief. 1.02. What is the ratio of the Debt(current US$) in Low income in 1982 to that in 1984?
Make the answer very short. 0.99. What is the ratio of the Debt(current US$) in Burkina Faso in 1982 to that in 1984?
Offer a very short reply. 1.05. What is the ratio of the Debt(current US$) in Cote d'Ivoire in 1982 to that in 1984?
Your answer should be compact. 1.66. What is the ratio of the Debt(current US$) of Low income in 1983 to that in 1984?
Your answer should be very brief. 0.95. What is the ratio of the Debt(current US$) of Burkina Faso in 1983 to that in 1984?
Your answer should be compact. 0.97. What is the ratio of the Debt(current US$) in Cote d'Ivoire in 1983 to that in 1984?
Offer a terse response. 1.62. What is the difference between the highest and the second highest Debt(current US$) in Low income?
Your response must be concise. 6.65e+07. What is the difference between the highest and the second highest Debt(current US$) in Burkina Faso?
Provide a short and direct response. 1.69e+07. What is the difference between the highest and the second highest Debt(current US$) of Cote d'Ivoire?
Keep it short and to the point. 2.42e+08. What is the difference between the highest and the lowest Debt(current US$) in Low income?
Provide a succinct answer. 8.18e+09. What is the difference between the highest and the lowest Debt(current US$) of Burkina Faso?
Offer a terse response. 1.64e+08. What is the difference between the highest and the lowest Debt(current US$) of Cote d'Ivoire?
Keep it short and to the point. 1.27e+09. 